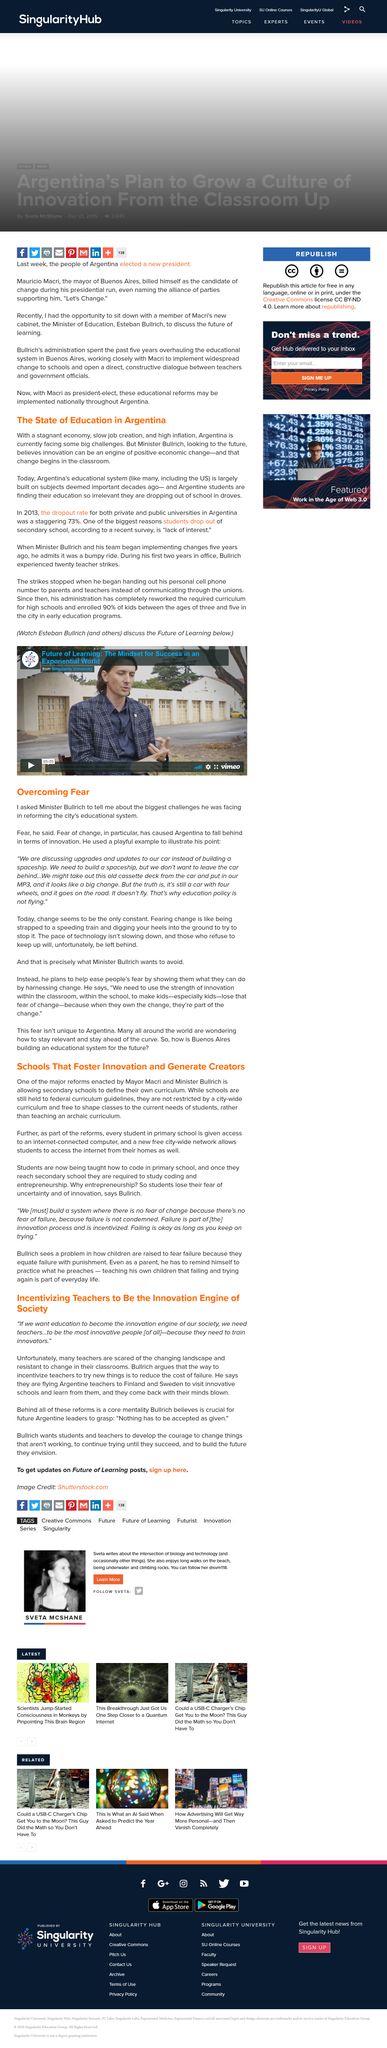Draw attention to some important aspects in this diagram. The article's subtitle is 'The state of Education in Argentina.' Yes, it is a part of the reforms enacted by Mayor Macri and Minister Bullrich, that every student in primary school is given access to an internet-connected computer. Change is the only constant in today's world, as what seems to be the only constant is constant change. Yes, schools are still required to follow federal curriculum guidelines. It is now a common practice for primary school students to be taught how to code. 